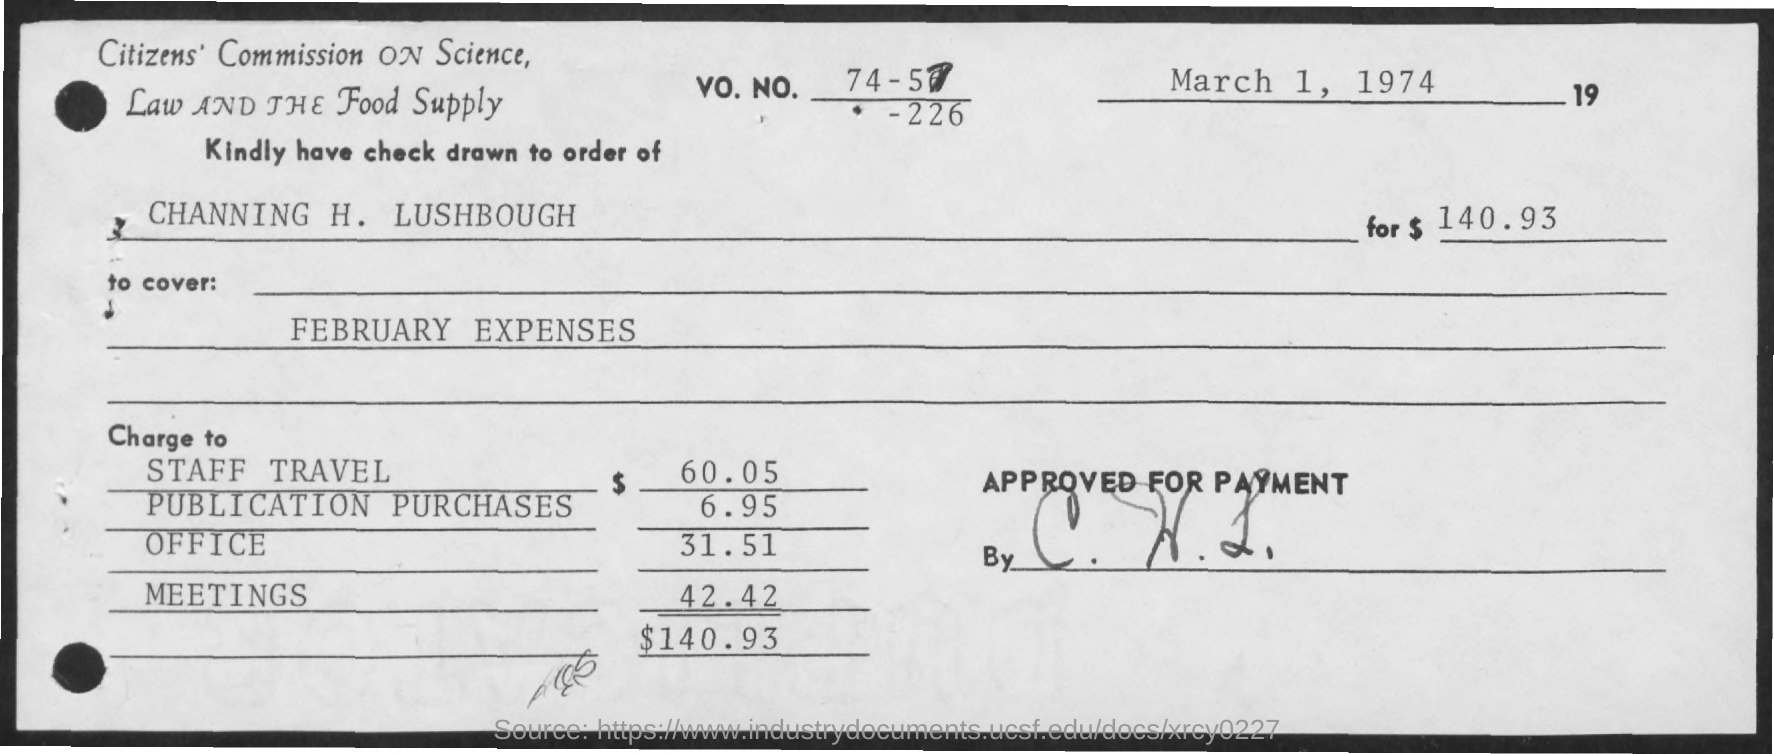Mention a couple of crucial points in this snapshot. The memorandum was dated March 1, 1974. In February, expenses are showing. 